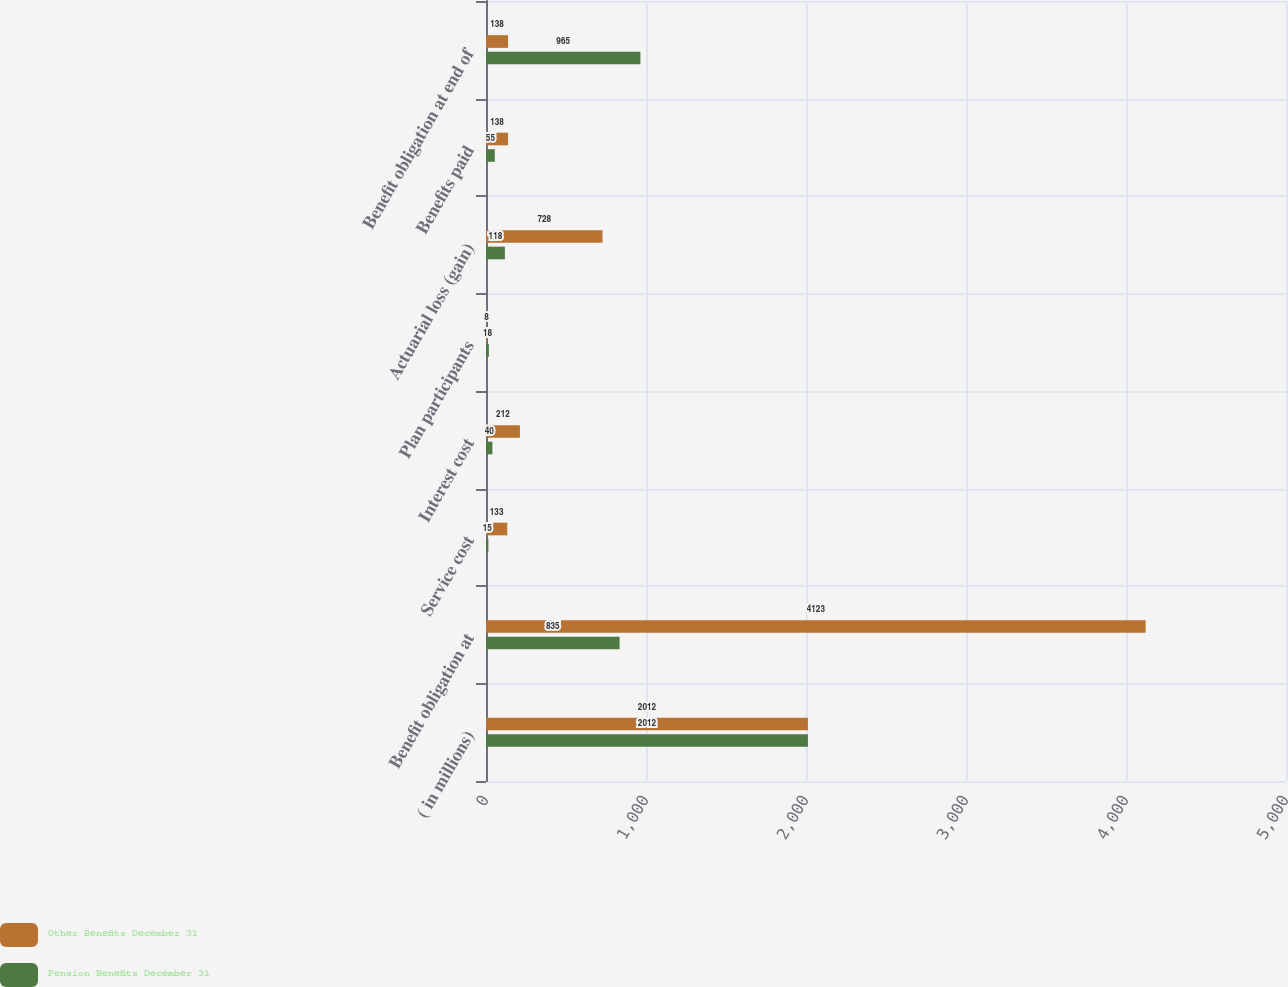Convert chart. <chart><loc_0><loc_0><loc_500><loc_500><stacked_bar_chart><ecel><fcel>( in millions)<fcel>Benefit obligation at<fcel>Service cost<fcel>Interest cost<fcel>Plan participants<fcel>Actuarial loss (gain)<fcel>Benefits paid<fcel>Benefit obligation at end of<nl><fcel>Other Benefits December 31<fcel>2012<fcel>4123<fcel>133<fcel>212<fcel>8<fcel>728<fcel>138<fcel>138<nl><fcel>Pension Benefits December 31<fcel>2012<fcel>835<fcel>15<fcel>40<fcel>18<fcel>118<fcel>55<fcel>965<nl></chart> 